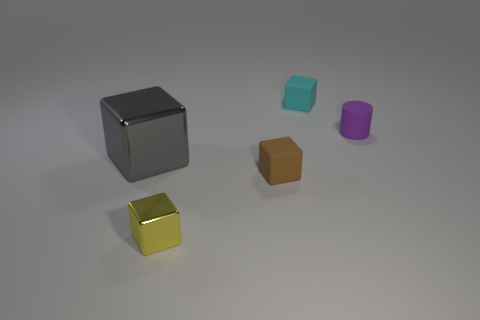Subtract all blue cubes. Subtract all green balls. How many cubes are left? 4 Add 3 big brown metal things. How many objects exist? 8 Subtract all cylinders. How many objects are left? 4 Subtract 0 yellow cylinders. How many objects are left? 5 Subtract all small matte objects. Subtract all cyan matte blocks. How many objects are left? 1 Add 2 tiny cyan cubes. How many tiny cyan cubes are left? 3 Add 1 gray cubes. How many gray cubes exist? 2 